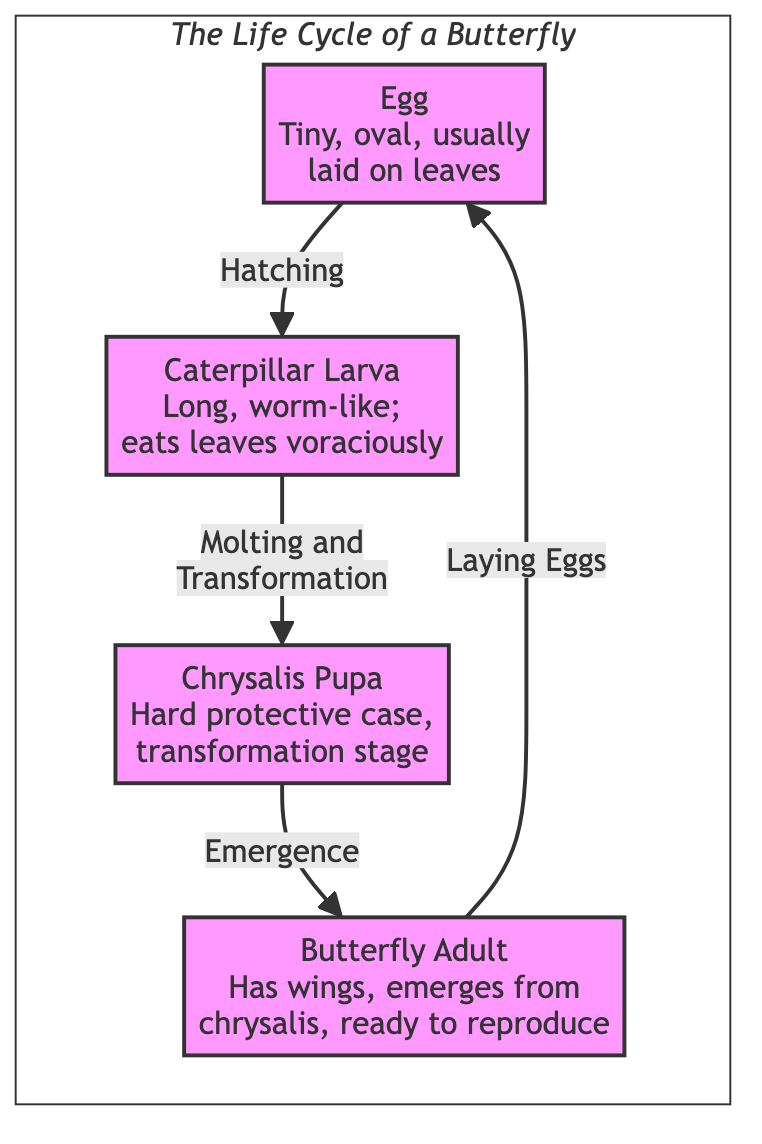What are the four stages in the life cycle of a butterfly? The diagram shows the four stages as Egg, Caterpillar Larva, Chrysalis Pupa, and Butterfly Adult. These stages are represented as distinct labeled nodes within the lifecycle subgraph.
Answer: Egg, Caterpillar Larva, Chrysalis Pupa, Butterfly Adult Which stage follows the Caterpillar Larva? According to the diagram, the arrow from Caterpillar Larva points to Chrysalis Pupa, indicating that this is the next stage in the life cycle after the Caterpillar Larva.
Answer: Chrysalis Pupa What is the primary action of the Butterfly Adult stage? The diagram indicates that the Butterfly Adult stage is associated with the action of laying Eggs, which is shown as an arrow pointing back to the Egg stage.
Answer: Laying Eggs How many main stages are presented in this life cycle diagram? The diagram clearly illustrates four main stages of a butterfly's life cycle, which corresponds to the number of distinct nodes in the lifecycle subgraph.
Answer: 4 What characteristic defines the Chrysalis Pupa stage? The diagram specifically describes the Chrysalis Pupa stage as a "Hard protective case, transformation stage," indicating its unique characteristic in the life cycle.
Answer: Hard protective case, transformation stage What happens during the hatching process? The flowchart shows that the hatching process leads from the Egg stage to the Caterpillar Larva stage, indicating that the Egg hatches to become a Caterpillar.
Answer: Hatching Which node indicates the voracious eating behavior of the Larva? The diagram characterizes the Caterpillar Larva with the phrase "eats leaves voraciously," highlighting this unique behavior at this stage of the life cycle.
Answer: Eats leaves voraciously What is the relationship between the Chrysalis Pupa and the Butterfly Adult stages? The relationship is described by the arrow pointing from the Chrysalis Pupa to the Butterfly Adult, indicating that the Pupa emerges into the Adult stage.
Answer: Emergence What is the process linking the Egg and the Caterpillar Larva stages? The diagram specifies that the process linking these two stages is called Hatching, which indicates the transformation from Egg to Caterpillar Larva.
Answer: Hatching 